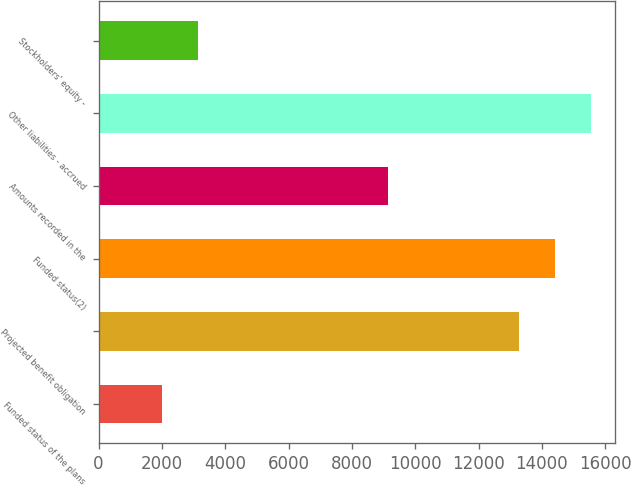Convert chart. <chart><loc_0><loc_0><loc_500><loc_500><bar_chart><fcel>Funded status of the plans<fcel>Projected benefit obligation<fcel>Funded status(2)<fcel>Amounts recorded in the<fcel>Other liabilities - accrued<fcel>Stockholders' equity -<nl><fcel>2008<fcel>13286<fcel>14413.8<fcel>9141<fcel>15541.6<fcel>3135.8<nl></chart> 